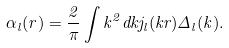<formula> <loc_0><loc_0><loc_500><loc_500>\alpha _ { l } ( r ) = \frac { 2 } { \pi } \int k ^ { 2 } d k j _ { l } ( k r ) \Delta _ { l } ( k ) .</formula> 